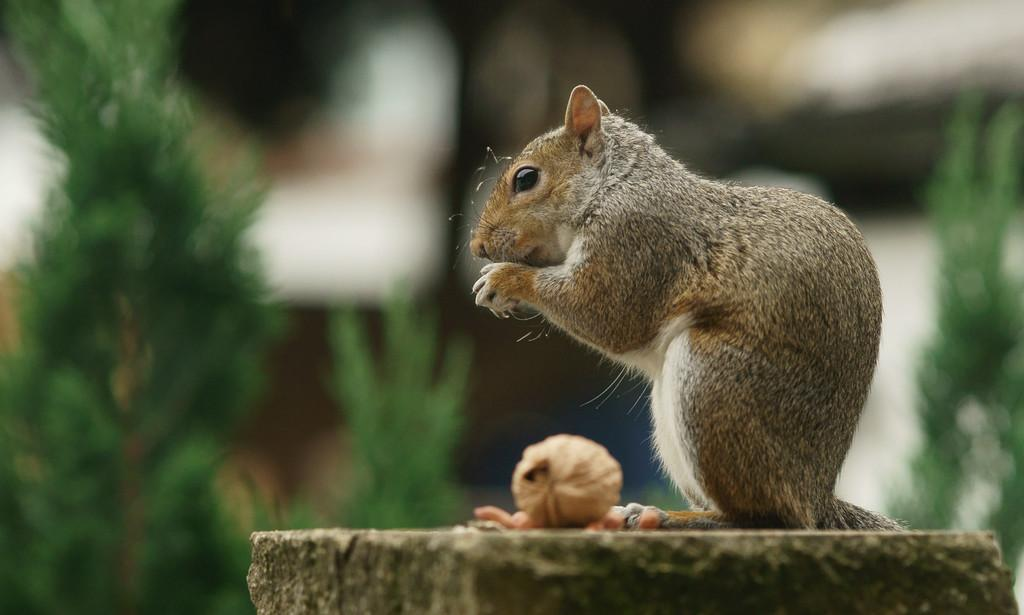What type of vegetation is on the right side of the image? There is a tree on the right side of the image. What animal can be seen in the middle of the image? There is a squirrel with food in the middle of the image. What is the squirrel standing on? The squirrel is standing on a rock. What type of vegetation is on the left side of the image? There is a tree on the left side of the image. What is unique about the left side tree? The left side tree is in blue. Where is the throne located in the image? There is no throne present in the image. How many pies are visible in the image? There are no pies visible in the image. 